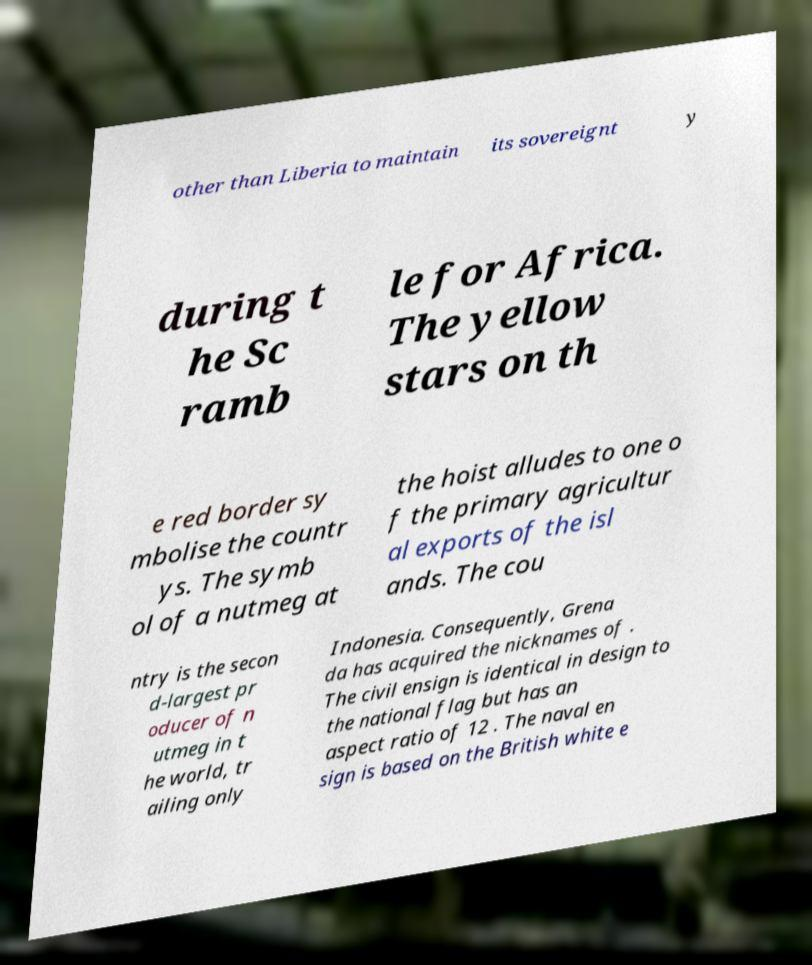Can you accurately transcribe the text from the provided image for me? other than Liberia to maintain its sovereignt y during t he Sc ramb le for Africa. The yellow stars on th e red border sy mbolise the countr ys. The symb ol of a nutmeg at the hoist alludes to one o f the primary agricultur al exports of the isl ands. The cou ntry is the secon d-largest pr oducer of n utmeg in t he world, tr ailing only Indonesia. Consequently, Grena da has acquired the nicknames of . The civil ensign is identical in design to the national flag but has an aspect ratio of 12 . The naval en sign is based on the British white e 